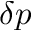Convert formula to latex. <formula><loc_0><loc_0><loc_500><loc_500>\delta p</formula> 